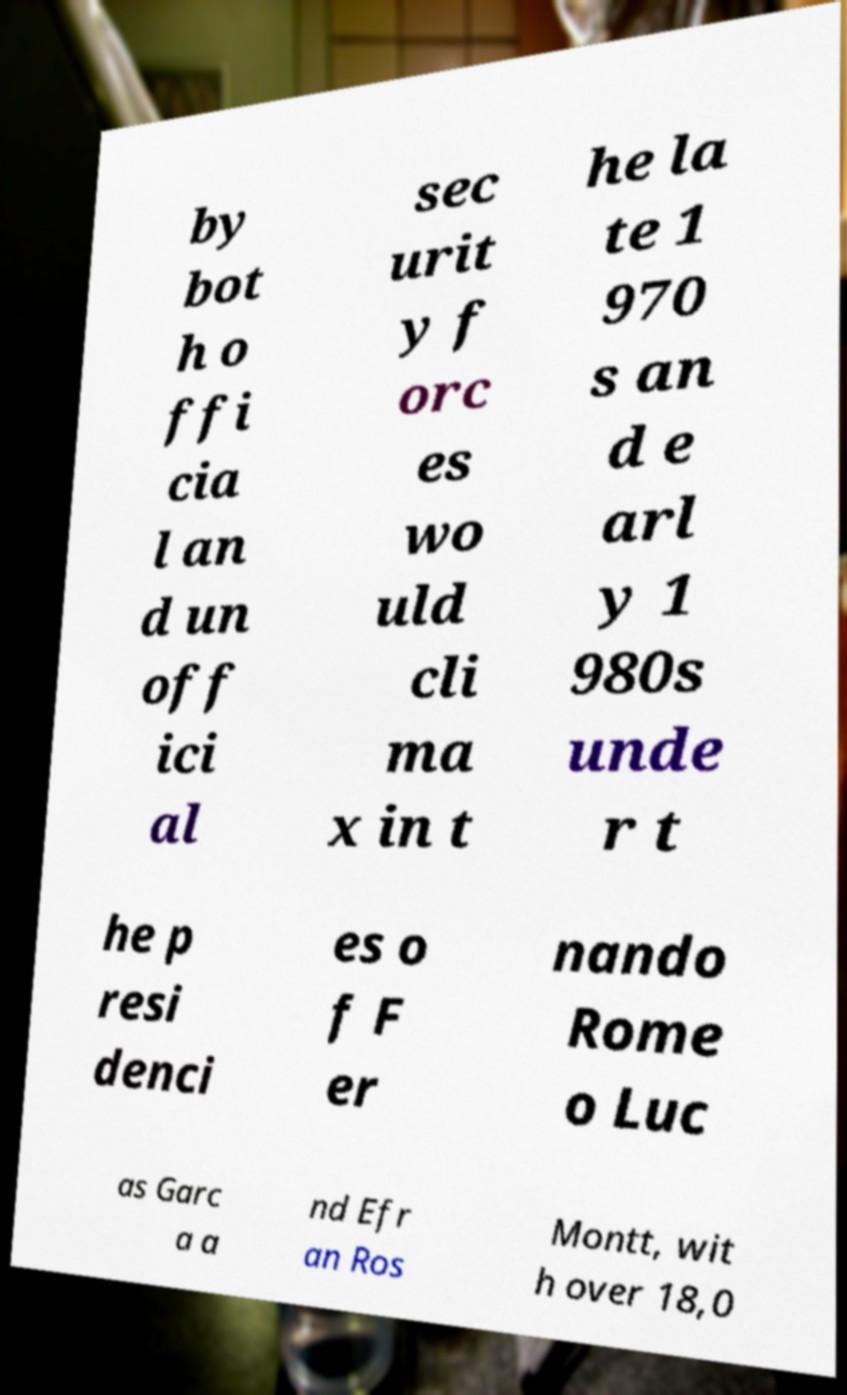Could you extract and type out the text from this image? by bot h o ffi cia l an d un off ici al sec urit y f orc es wo uld cli ma x in t he la te 1 970 s an d e arl y 1 980s unde r t he p resi denci es o f F er nando Rome o Luc as Garc a a nd Efr an Ros Montt, wit h over 18,0 